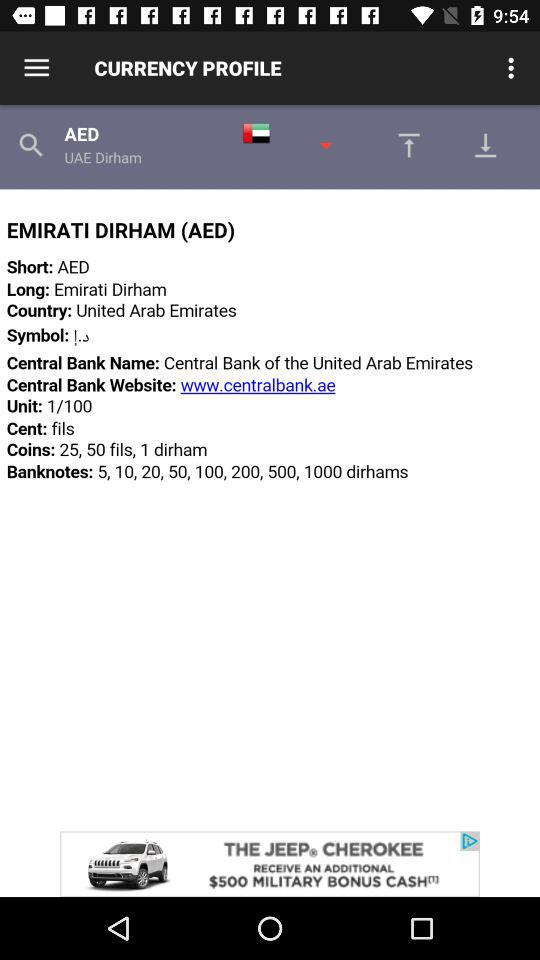How many banknotes are there for the Emirati Dirham?
Answer the question using a single word or phrase. 8 